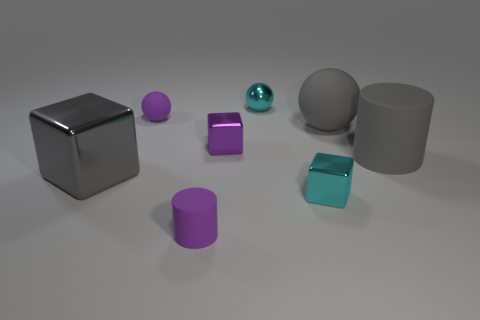Add 1 gray metallic blocks. How many objects exist? 9 Subtract all big cubes. How many cubes are left? 2 Subtract all gray cylinders. How many cylinders are left? 1 Subtract 1 cylinders. How many cylinders are left? 1 Subtract all cylinders. How many objects are left? 6 Add 2 cubes. How many cubes are left? 5 Add 4 large green things. How many large green things exist? 4 Subtract 1 purple cylinders. How many objects are left? 7 Subtract all red blocks. Subtract all gray balls. How many blocks are left? 3 Subtract all small rubber objects. Subtract all cylinders. How many objects are left? 4 